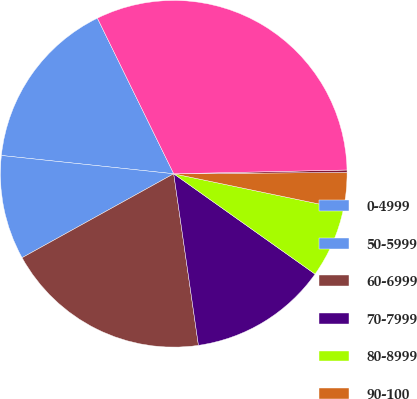Convert chart to OTSL. <chart><loc_0><loc_0><loc_500><loc_500><pie_chart><fcel>0-4999<fcel>50-5999<fcel>60-6999<fcel>70-7999<fcel>80-8999<fcel>90-100<fcel>Greater than 100<fcel>Total Retail<nl><fcel>16.06%<fcel>9.73%<fcel>19.23%<fcel>12.9%<fcel>6.56%<fcel>3.39%<fcel>0.22%<fcel>31.91%<nl></chart> 